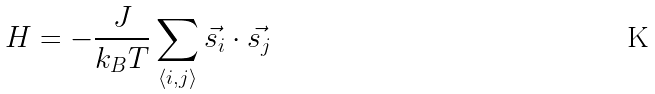Convert formula to latex. <formula><loc_0><loc_0><loc_500><loc_500>H = - \frac { J } { k _ { B } T } \sum _ { \langle i , j \rangle } \vec { s _ { i } } \cdot \vec { s _ { j } }</formula> 